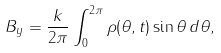Convert formula to latex. <formula><loc_0><loc_0><loc_500><loc_500>B _ { y } = \frac { k } { 2 \pi } \int _ { 0 } ^ { 2 \pi } \rho ( \theta , t ) \sin \theta \, d \theta ,</formula> 